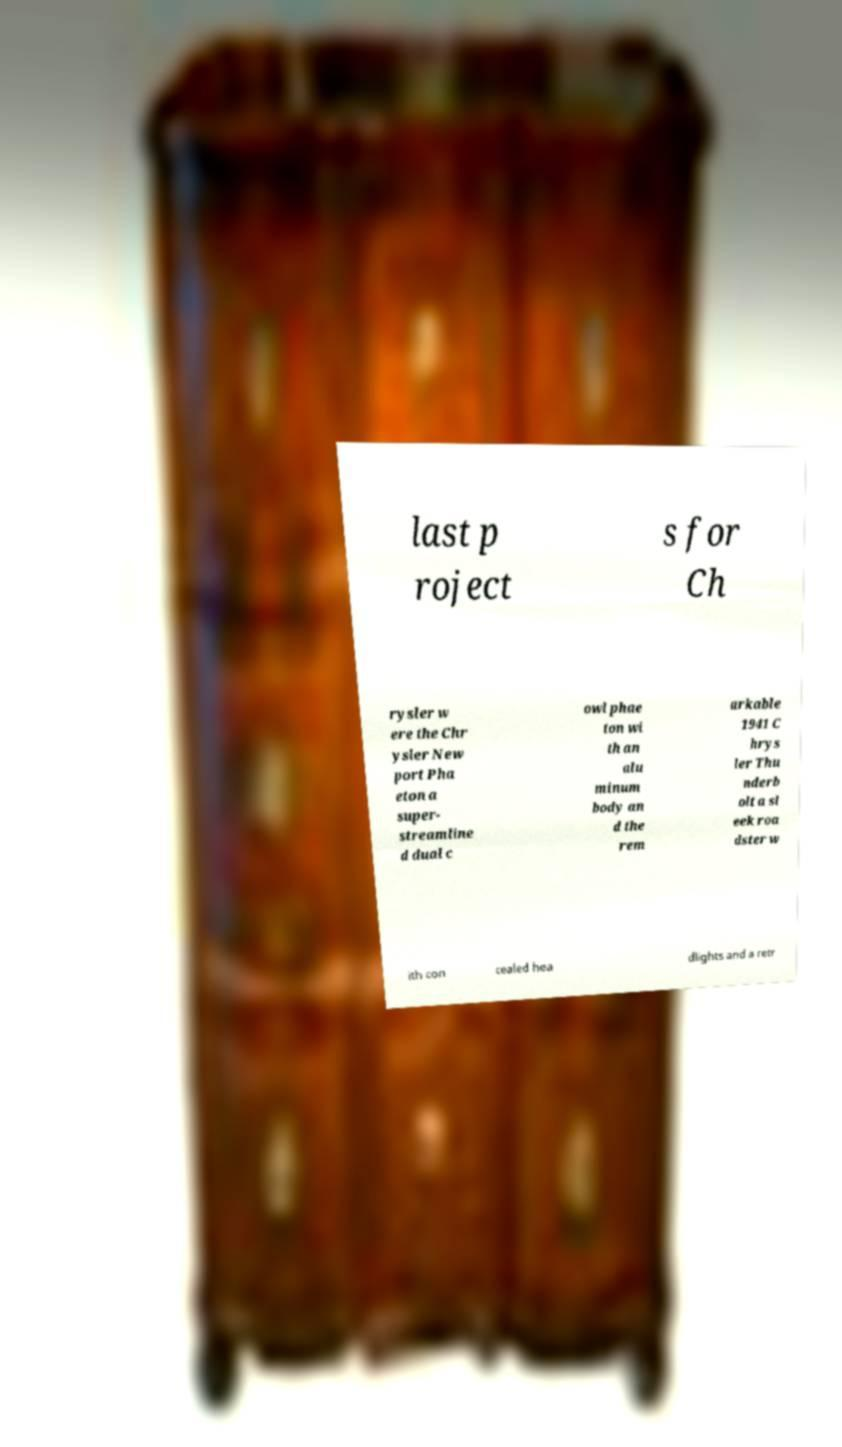Please identify and transcribe the text found in this image. last p roject s for Ch rysler w ere the Chr ysler New port Pha eton a super- streamline d dual c owl phae ton wi th an alu minum body an d the rem arkable 1941 C hrys ler Thu nderb olt a sl eek roa dster w ith con cealed hea dlights and a retr 